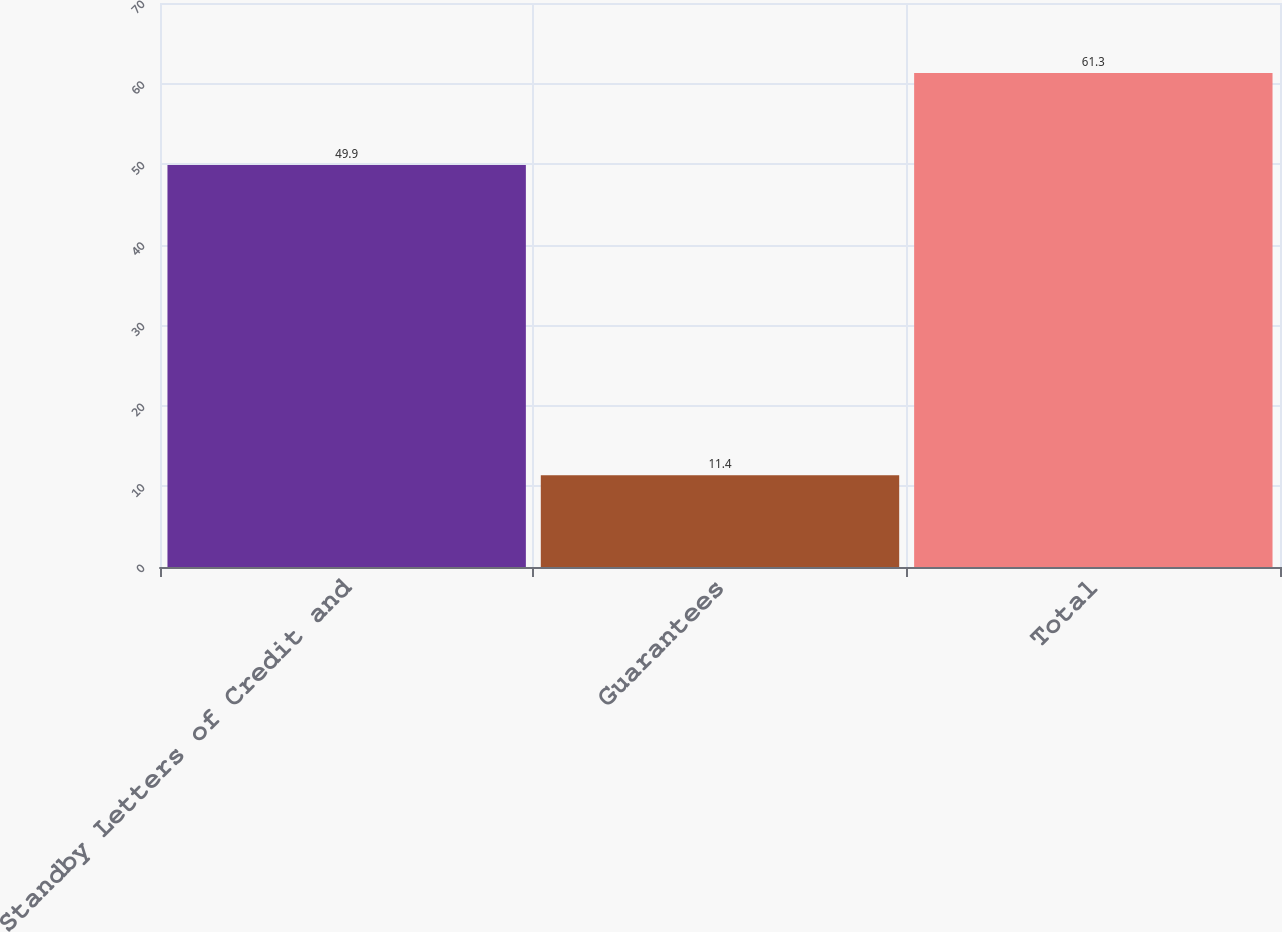Convert chart to OTSL. <chart><loc_0><loc_0><loc_500><loc_500><bar_chart><fcel>Standby Letters of Credit and<fcel>Guarantees<fcel>Total<nl><fcel>49.9<fcel>11.4<fcel>61.3<nl></chart> 